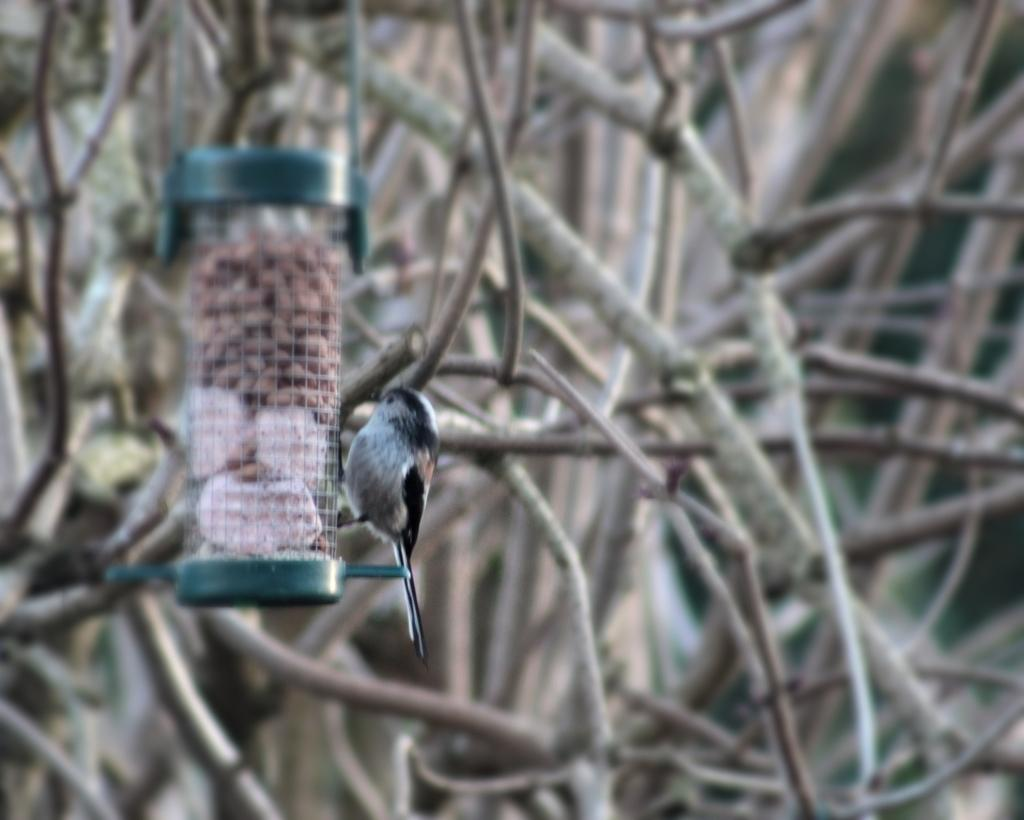What is the main subject in the center of the image? There is a bird feeder in the center of the image. Are there any animals present in the image? Yes, there is a bird on the bird feeder. Can you describe the background of the image? The background of the image is blurred. What type of lettuce is growing in the image? There is no lettuce present in the image. How many boats can be seen in the image? There are no boats present in the image. 